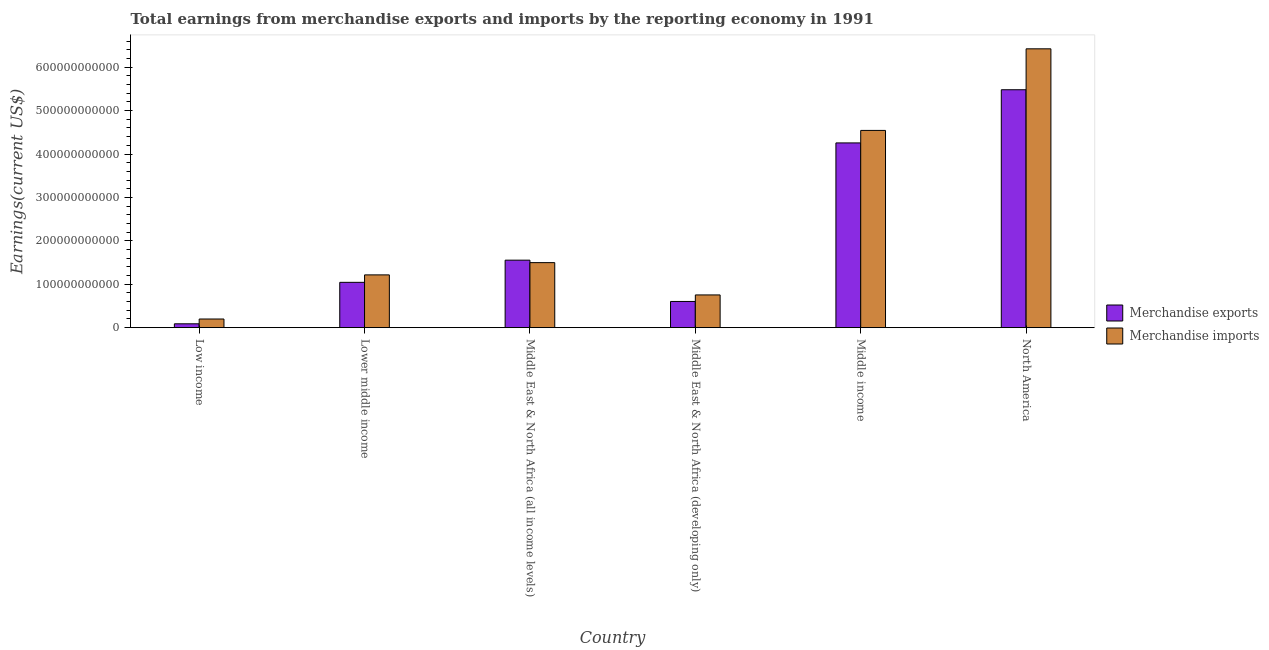How many bars are there on the 4th tick from the left?
Offer a terse response. 2. How many bars are there on the 6th tick from the right?
Provide a short and direct response. 2. What is the label of the 6th group of bars from the left?
Provide a succinct answer. North America. In how many cases, is the number of bars for a given country not equal to the number of legend labels?
Offer a very short reply. 0. What is the earnings from merchandise imports in Low income?
Make the answer very short. 2.00e+1. Across all countries, what is the maximum earnings from merchandise exports?
Your answer should be compact. 5.48e+11. Across all countries, what is the minimum earnings from merchandise imports?
Your answer should be very brief. 2.00e+1. In which country was the earnings from merchandise imports maximum?
Give a very brief answer. North America. In which country was the earnings from merchandise imports minimum?
Provide a short and direct response. Low income. What is the total earnings from merchandise imports in the graph?
Your answer should be compact. 1.46e+12. What is the difference between the earnings from merchandise imports in Low income and that in Middle East & North Africa (developing only)?
Provide a succinct answer. -5.54e+1. What is the difference between the earnings from merchandise imports in Middle East & North Africa (all income levels) and the earnings from merchandise exports in North America?
Your response must be concise. -3.98e+11. What is the average earnings from merchandise exports per country?
Give a very brief answer. 2.17e+11. What is the difference between the earnings from merchandise imports and earnings from merchandise exports in Low income?
Give a very brief answer. 1.11e+1. What is the ratio of the earnings from merchandise exports in Low income to that in Middle income?
Provide a short and direct response. 0.02. Is the earnings from merchandise imports in Low income less than that in Middle East & North Africa (developing only)?
Your response must be concise. Yes. Is the difference between the earnings from merchandise imports in Lower middle income and Middle East & North Africa (developing only) greater than the difference between the earnings from merchandise exports in Lower middle income and Middle East & North Africa (developing only)?
Provide a succinct answer. Yes. What is the difference between the highest and the second highest earnings from merchandise exports?
Your answer should be compact. 1.22e+11. What is the difference between the highest and the lowest earnings from merchandise imports?
Offer a terse response. 6.22e+11. In how many countries, is the earnings from merchandise imports greater than the average earnings from merchandise imports taken over all countries?
Provide a short and direct response. 2. What does the 1st bar from the left in Lower middle income represents?
Ensure brevity in your answer.  Merchandise exports. What does the 2nd bar from the right in Middle East & North Africa (developing only) represents?
Your answer should be very brief. Merchandise exports. Are all the bars in the graph horizontal?
Offer a very short reply. No. How many countries are there in the graph?
Provide a succinct answer. 6. What is the difference between two consecutive major ticks on the Y-axis?
Make the answer very short. 1.00e+11. Does the graph contain any zero values?
Provide a short and direct response. No. Does the graph contain grids?
Your answer should be very brief. No. How many legend labels are there?
Ensure brevity in your answer.  2. How are the legend labels stacked?
Your response must be concise. Vertical. What is the title of the graph?
Your answer should be compact. Total earnings from merchandise exports and imports by the reporting economy in 1991. Does "constant 2005 US$" appear as one of the legend labels in the graph?
Ensure brevity in your answer.  No. What is the label or title of the X-axis?
Keep it short and to the point. Country. What is the label or title of the Y-axis?
Offer a terse response. Earnings(current US$). What is the Earnings(current US$) of Merchandise exports in Low income?
Offer a terse response. 8.90e+09. What is the Earnings(current US$) in Merchandise imports in Low income?
Ensure brevity in your answer.  2.00e+1. What is the Earnings(current US$) of Merchandise exports in Lower middle income?
Your answer should be compact. 1.04e+11. What is the Earnings(current US$) of Merchandise imports in Lower middle income?
Your answer should be compact. 1.22e+11. What is the Earnings(current US$) of Merchandise exports in Middle East & North Africa (all income levels)?
Ensure brevity in your answer.  1.55e+11. What is the Earnings(current US$) of Merchandise imports in Middle East & North Africa (all income levels)?
Provide a succinct answer. 1.50e+11. What is the Earnings(current US$) in Merchandise exports in Middle East & North Africa (developing only)?
Make the answer very short. 6.03e+1. What is the Earnings(current US$) of Merchandise imports in Middle East & North Africa (developing only)?
Ensure brevity in your answer.  7.54e+1. What is the Earnings(current US$) in Merchandise exports in Middle income?
Offer a terse response. 4.26e+11. What is the Earnings(current US$) in Merchandise imports in Middle income?
Keep it short and to the point. 4.54e+11. What is the Earnings(current US$) in Merchandise exports in North America?
Offer a very short reply. 5.48e+11. What is the Earnings(current US$) in Merchandise imports in North America?
Make the answer very short. 6.42e+11. Across all countries, what is the maximum Earnings(current US$) of Merchandise exports?
Offer a very short reply. 5.48e+11. Across all countries, what is the maximum Earnings(current US$) of Merchandise imports?
Give a very brief answer. 6.42e+11. Across all countries, what is the minimum Earnings(current US$) of Merchandise exports?
Your response must be concise. 8.90e+09. Across all countries, what is the minimum Earnings(current US$) of Merchandise imports?
Your answer should be very brief. 2.00e+1. What is the total Earnings(current US$) in Merchandise exports in the graph?
Make the answer very short. 1.30e+12. What is the total Earnings(current US$) in Merchandise imports in the graph?
Ensure brevity in your answer.  1.46e+12. What is the difference between the Earnings(current US$) of Merchandise exports in Low income and that in Lower middle income?
Provide a short and direct response. -9.55e+1. What is the difference between the Earnings(current US$) of Merchandise imports in Low income and that in Lower middle income?
Provide a succinct answer. -1.02e+11. What is the difference between the Earnings(current US$) in Merchandise exports in Low income and that in Middle East & North Africa (all income levels)?
Your response must be concise. -1.47e+11. What is the difference between the Earnings(current US$) of Merchandise imports in Low income and that in Middle East & North Africa (all income levels)?
Offer a terse response. -1.30e+11. What is the difference between the Earnings(current US$) in Merchandise exports in Low income and that in Middle East & North Africa (developing only)?
Offer a terse response. -5.14e+1. What is the difference between the Earnings(current US$) in Merchandise imports in Low income and that in Middle East & North Africa (developing only)?
Keep it short and to the point. -5.54e+1. What is the difference between the Earnings(current US$) of Merchandise exports in Low income and that in Middle income?
Make the answer very short. -4.17e+11. What is the difference between the Earnings(current US$) in Merchandise imports in Low income and that in Middle income?
Your answer should be compact. -4.34e+11. What is the difference between the Earnings(current US$) of Merchandise exports in Low income and that in North America?
Make the answer very short. -5.39e+11. What is the difference between the Earnings(current US$) in Merchandise imports in Low income and that in North America?
Your response must be concise. -6.22e+11. What is the difference between the Earnings(current US$) of Merchandise exports in Lower middle income and that in Middle East & North Africa (all income levels)?
Your answer should be compact. -5.11e+1. What is the difference between the Earnings(current US$) in Merchandise imports in Lower middle income and that in Middle East & North Africa (all income levels)?
Ensure brevity in your answer.  -2.82e+1. What is the difference between the Earnings(current US$) in Merchandise exports in Lower middle income and that in Middle East & North Africa (developing only)?
Your response must be concise. 4.41e+1. What is the difference between the Earnings(current US$) in Merchandise imports in Lower middle income and that in Middle East & North Africa (developing only)?
Your response must be concise. 4.62e+1. What is the difference between the Earnings(current US$) of Merchandise exports in Lower middle income and that in Middle income?
Give a very brief answer. -3.21e+11. What is the difference between the Earnings(current US$) of Merchandise imports in Lower middle income and that in Middle income?
Offer a terse response. -3.33e+11. What is the difference between the Earnings(current US$) of Merchandise exports in Lower middle income and that in North America?
Your answer should be very brief. -4.44e+11. What is the difference between the Earnings(current US$) of Merchandise imports in Lower middle income and that in North America?
Offer a very short reply. -5.21e+11. What is the difference between the Earnings(current US$) of Merchandise exports in Middle East & North Africa (all income levels) and that in Middle East & North Africa (developing only)?
Your answer should be compact. 9.51e+1. What is the difference between the Earnings(current US$) in Merchandise imports in Middle East & North Africa (all income levels) and that in Middle East & North Africa (developing only)?
Ensure brevity in your answer.  7.44e+1. What is the difference between the Earnings(current US$) in Merchandise exports in Middle East & North Africa (all income levels) and that in Middle income?
Provide a succinct answer. -2.70e+11. What is the difference between the Earnings(current US$) of Merchandise imports in Middle East & North Africa (all income levels) and that in Middle income?
Your response must be concise. -3.05e+11. What is the difference between the Earnings(current US$) of Merchandise exports in Middle East & North Africa (all income levels) and that in North America?
Provide a short and direct response. -3.93e+11. What is the difference between the Earnings(current US$) in Merchandise imports in Middle East & North Africa (all income levels) and that in North America?
Provide a short and direct response. -4.93e+11. What is the difference between the Earnings(current US$) of Merchandise exports in Middle East & North Africa (developing only) and that in Middle income?
Provide a succinct answer. -3.65e+11. What is the difference between the Earnings(current US$) in Merchandise imports in Middle East & North Africa (developing only) and that in Middle income?
Your answer should be very brief. -3.79e+11. What is the difference between the Earnings(current US$) of Merchandise exports in Middle East & North Africa (developing only) and that in North America?
Your response must be concise. -4.88e+11. What is the difference between the Earnings(current US$) of Merchandise imports in Middle East & North Africa (developing only) and that in North America?
Your answer should be compact. -5.67e+11. What is the difference between the Earnings(current US$) of Merchandise exports in Middle income and that in North America?
Your answer should be very brief. -1.22e+11. What is the difference between the Earnings(current US$) of Merchandise imports in Middle income and that in North America?
Give a very brief answer. -1.88e+11. What is the difference between the Earnings(current US$) in Merchandise exports in Low income and the Earnings(current US$) in Merchandise imports in Lower middle income?
Your response must be concise. -1.13e+11. What is the difference between the Earnings(current US$) in Merchandise exports in Low income and the Earnings(current US$) in Merchandise imports in Middle East & North Africa (all income levels)?
Give a very brief answer. -1.41e+11. What is the difference between the Earnings(current US$) in Merchandise exports in Low income and the Earnings(current US$) in Merchandise imports in Middle East & North Africa (developing only)?
Give a very brief answer. -6.65e+1. What is the difference between the Earnings(current US$) of Merchandise exports in Low income and the Earnings(current US$) of Merchandise imports in Middle income?
Offer a very short reply. -4.45e+11. What is the difference between the Earnings(current US$) of Merchandise exports in Low income and the Earnings(current US$) of Merchandise imports in North America?
Give a very brief answer. -6.33e+11. What is the difference between the Earnings(current US$) of Merchandise exports in Lower middle income and the Earnings(current US$) of Merchandise imports in Middle East & North Africa (all income levels)?
Provide a short and direct response. -4.54e+1. What is the difference between the Earnings(current US$) in Merchandise exports in Lower middle income and the Earnings(current US$) in Merchandise imports in Middle East & North Africa (developing only)?
Give a very brief answer. 2.90e+1. What is the difference between the Earnings(current US$) in Merchandise exports in Lower middle income and the Earnings(current US$) in Merchandise imports in Middle income?
Your response must be concise. -3.50e+11. What is the difference between the Earnings(current US$) in Merchandise exports in Lower middle income and the Earnings(current US$) in Merchandise imports in North America?
Your answer should be very brief. -5.38e+11. What is the difference between the Earnings(current US$) of Merchandise exports in Middle East & North Africa (all income levels) and the Earnings(current US$) of Merchandise imports in Middle East & North Africa (developing only)?
Keep it short and to the point. 8.01e+1. What is the difference between the Earnings(current US$) of Merchandise exports in Middle East & North Africa (all income levels) and the Earnings(current US$) of Merchandise imports in Middle income?
Ensure brevity in your answer.  -2.99e+11. What is the difference between the Earnings(current US$) in Merchandise exports in Middle East & North Africa (all income levels) and the Earnings(current US$) in Merchandise imports in North America?
Your answer should be very brief. -4.87e+11. What is the difference between the Earnings(current US$) of Merchandise exports in Middle East & North Africa (developing only) and the Earnings(current US$) of Merchandise imports in Middle income?
Keep it short and to the point. -3.94e+11. What is the difference between the Earnings(current US$) in Merchandise exports in Middle East & North Africa (developing only) and the Earnings(current US$) in Merchandise imports in North America?
Provide a succinct answer. -5.82e+11. What is the difference between the Earnings(current US$) in Merchandise exports in Middle income and the Earnings(current US$) in Merchandise imports in North America?
Offer a terse response. -2.17e+11. What is the average Earnings(current US$) in Merchandise exports per country?
Keep it short and to the point. 2.17e+11. What is the average Earnings(current US$) of Merchandise imports per country?
Provide a succinct answer. 2.44e+11. What is the difference between the Earnings(current US$) of Merchandise exports and Earnings(current US$) of Merchandise imports in Low income?
Your response must be concise. -1.11e+1. What is the difference between the Earnings(current US$) of Merchandise exports and Earnings(current US$) of Merchandise imports in Lower middle income?
Your answer should be very brief. -1.72e+1. What is the difference between the Earnings(current US$) of Merchandise exports and Earnings(current US$) of Merchandise imports in Middle East & North Africa (all income levels)?
Keep it short and to the point. 5.69e+09. What is the difference between the Earnings(current US$) in Merchandise exports and Earnings(current US$) in Merchandise imports in Middle East & North Africa (developing only)?
Provide a short and direct response. -1.50e+1. What is the difference between the Earnings(current US$) in Merchandise exports and Earnings(current US$) in Merchandise imports in Middle income?
Offer a very short reply. -2.88e+1. What is the difference between the Earnings(current US$) of Merchandise exports and Earnings(current US$) of Merchandise imports in North America?
Provide a short and direct response. -9.43e+1. What is the ratio of the Earnings(current US$) of Merchandise exports in Low income to that in Lower middle income?
Offer a terse response. 0.09. What is the ratio of the Earnings(current US$) in Merchandise imports in Low income to that in Lower middle income?
Offer a very short reply. 0.16. What is the ratio of the Earnings(current US$) of Merchandise exports in Low income to that in Middle East & North Africa (all income levels)?
Give a very brief answer. 0.06. What is the ratio of the Earnings(current US$) in Merchandise imports in Low income to that in Middle East & North Africa (all income levels)?
Ensure brevity in your answer.  0.13. What is the ratio of the Earnings(current US$) in Merchandise exports in Low income to that in Middle East & North Africa (developing only)?
Offer a terse response. 0.15. What is the ratio of the Earnings(current US$) of Merchandise imports in Low income to that in Middle East & North Africa (developing only)?
Provide a short and direct response. 0.26. What is the ratio of the Earnings(current US$) in Merchandise exports in Low income to that in Middle income?
Make the answer very short. 0.02. What is the ratio of the Earnings(current US$) of Merchandise imports in Low income to that in Middle income?
Provide a succinct answer. 0.04. What is the ratio of the Earnings(current US$) in Merchandise exports in Low income to that in North America?
Ensure brevity in your answer.  0.02. What is the ratio of the Earnings(current US$) of Merchandise imports in Low income to that in North America?
Keep it short and to the point. 0.03. What is the ratio of the Earnings(current US$) of Merchandise exports in Lower middle income to that in Middle East & North Africa (all income levels)?
Your answer should be compact. 0.67. What is the ratio of the Earnings(current US$) in Merchandise imports in Lower middle income to that in Middle East & North Africa (all income levels)?
Make the answer very short. 0.81. What is the ratio of the Earnings(current US$) of Merchandise exports in Lower middle income to that in Middle East & North Africa (developing only)?
Give a very brief answer. 1.73. What is the ratio of the Earnings(current US$) in Merchandise imports in Lower middle income to that in Middle East & North Africa (developing only)?
Offer a very short reply. 1.61. What is the ratio of the Earnings(current US$) in Merchandise exports in Lower middle income to that in Middle income?
Provide a succinct answer. 0.25. What is the ratio of the Earnings(current US$) in Merchandise imports in Lower middle income to that in Middle income?
Offer a very short reply. 0.27. What is the ratio of the Earnings(current US$) in Merchandise exports in Lower middle income to that in North America?
Your answer should be compact. 0.19. What is the ratio of the Earnings(current US$) of Merchandise imports in Lower middle income to that in North America?
Provide a short and direct response. 0.19. What is the ratio of the Earnings(current US$) of Merchandise exports in Middle East & North Africa (all income levels) to that in Middle East & North Africa (developing only)?
Ensure brevity in your answer.  2.58. What is the ratio of the Earnings(current US$) in Merchandise imports in Middle East & North Africa (all income levels) to that in Middle East & North Africa (developing only)?
Ensure brevity in your answer.  1.99. What is the ratio of the Earnings(current US$) in Merchandise exports in Middle East & North Africa (all income levels) to that in Middle income?
Provide a succinct answer. 0.37. What is the ratio of the Earnings(current US$) of Merchandise imports in Middle East & North Africa (all income levels) to that in Middle income?
Offer a terse response. 0.33. What is the ratio of the Earnings(current US$) of Merchandise exports in Middle East & North Africa (all income levels) to that in North America?
Provide a succinct answer. 0.28. What is the ratio of the Earnings(current US$) in Merchandise imports in Middle East & North Africa (all income levels) to that in North America?
Offer a terse response. 0.23. What is the ratio of the Earnings(current US$) of Merchandise exports in Middle East & North Africa (developing only) to that in Middle income?
Provide a short and direct response. 0.14. What is the ratio of the Earnings(current US$) of Merchandise imports in Middle East & North Africa (developing only) to that in Middle income?
Your answer should be very brief. 0.17. What is the ratio of the Earnings(current US$) in Merchandise exports in Middle East & North Africa (developing only) to that in North America?
Provide a short and direct response. 0.11. What is the ratio of the Earnings(current US$) in Merchandise imports in Middle East & North Africa (developing only) to that in North America?
Provide a succinct answer. 0.12. What is the ratio of the Earnings(current US$) in Merchandise exports in Middle income to that in North America?
Provide a succinct answer. 0.78. What is the ratio of the Earnings(current US$) in Merchandise imports in Middle income to that in North America?
Ensure brevity in your answer.  0.71. What is the difference between the highest and the second highest Earnings(current US$) of Merchandise exports?
Provide a succinct answer. 1.22e+11. What is the difference between the highest and the second highest Earnings(current US$) in Merchandise imports?
Ensure brevity in your answer.  1.88e+11. What is the difference between the highest and the lowest Earnings(current US$) in Merchandise exports?
Make the answer very short. 5.39e+11. What is the difference between the highest and the lowest Earnings(current US$) in Merchandise imports?
Offer a very short reply. 6.22e+11. 